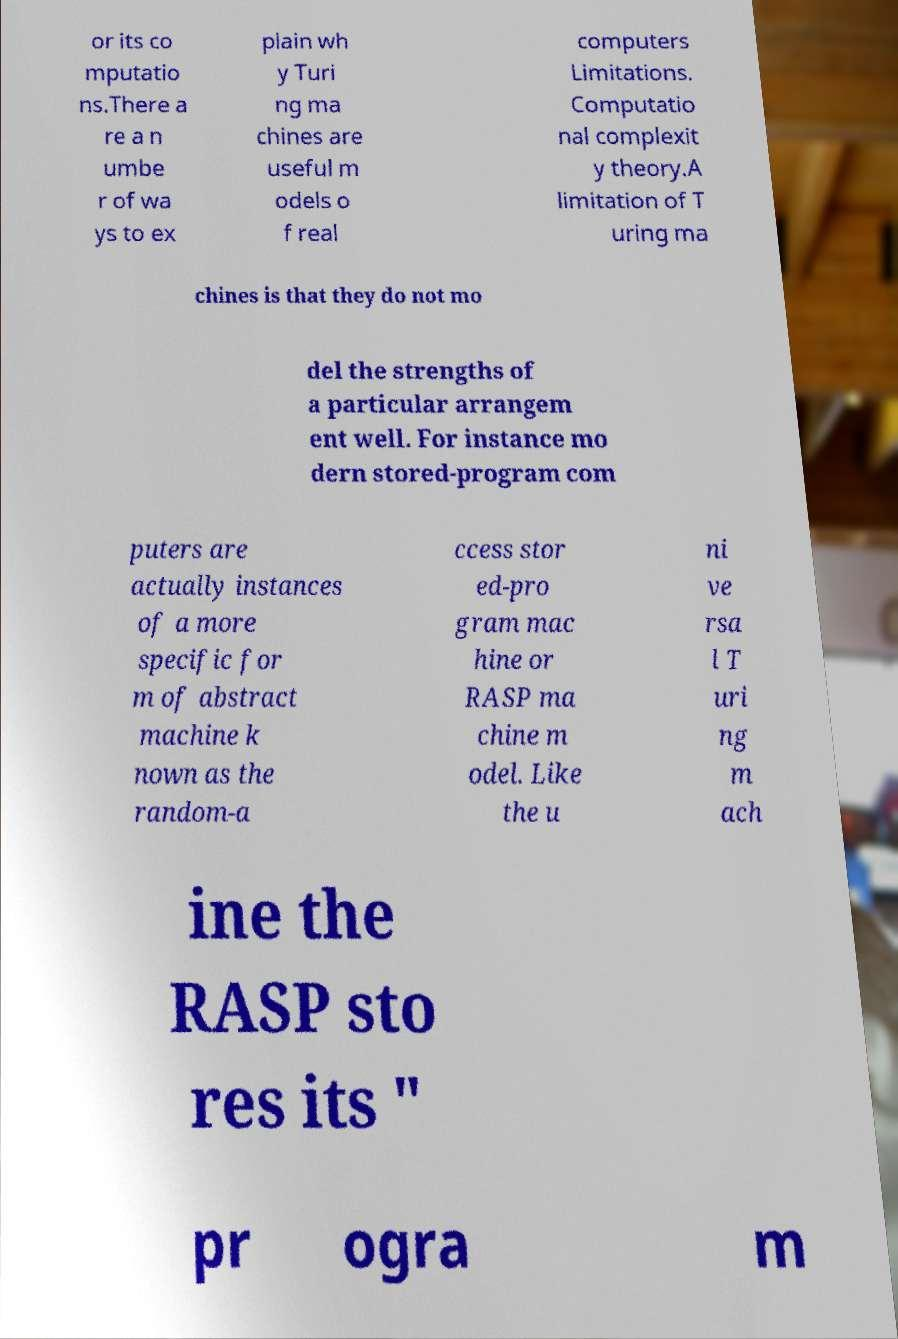What messages or text are displayed in this image? I need them in a readable, typed format. or its co mputatio ns.There a re a n umbe r of wa ys to ex plain wh y Turi ng ma chines are useful m odels o f real computers Limitations. Computatio nal complexit y theory.A limitation of T uring ma chines is that they do not mo del the strengths of a particular arrangem ent well. For instance mo dern stored-program com puters are actually instances of a more specific for m of abstract machine k nown as the random-a ccess stor ed-pro gram mac hine or RASP ma chine m odel. Like the u ni ve rsa l T uri ng m ach ine the RASP sto res its " pr ogra m 